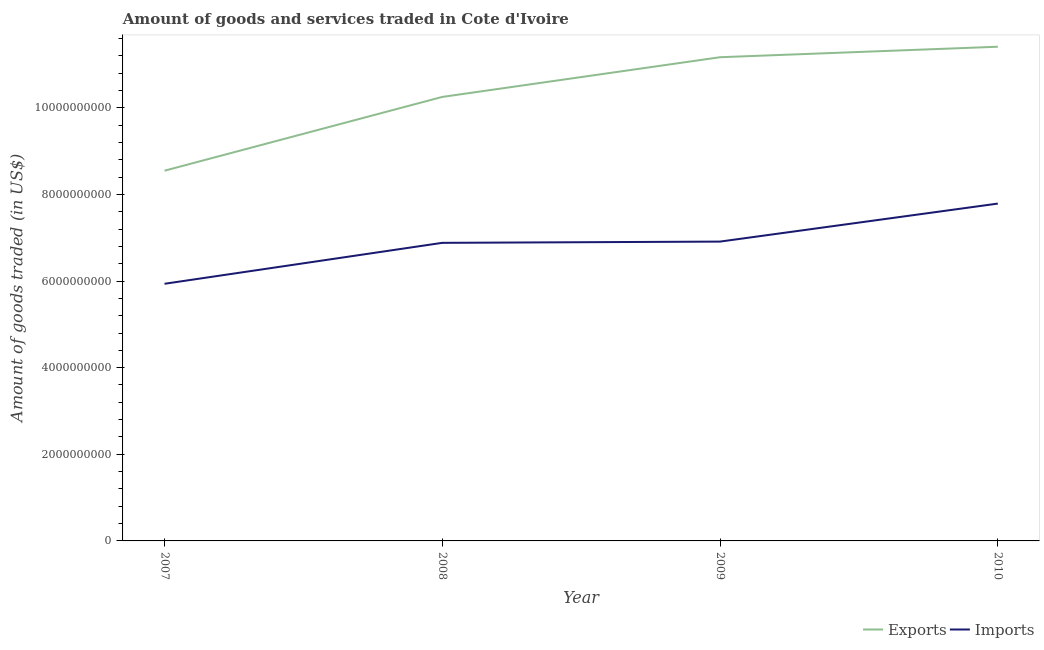Is the number of lines equal to the number of legend labels?
Ensure brevity in your answer.  Yes. What is the amount of goods imported in 2009?
Give a very brief answer. 6.91e+09. Across all years, what is the maximum amount of goods exported?
Offer a very short reply. 1.14e+1. Across all years, what is the minimum amount of goods imported?
Give a very brief answer. 5.94e+09. In which year was the amount of goods imported maximum?
Provide a short and direct response. 2010. What is the total amount of goods exported in the graph?
Your answer should be compact. 4.14e+1. What is the difference between the amount of goods exported in 2007 and that in 2009?
Ensure brevity in your answer.  -2.62e+09. What is the difference between the amount of goods imported in 2008 and the amount of goods exported in 2009?
Your response must be concise. -4.29e+09. What is the average amount of goods exported per year?
Your response must be concise. 1.03e+1. In the year 2010, what is the difference between the amount of goods exported and amount of goods imported?
Give a very brief answer. 3.62e+09. What is the ratio of the amount of goods exported in 2007 to that in 2008?
Your response must be concise. 0.83. Is the amount of goods imported in 2008 less than that in 2010?
Keep it short and to the point. Yes. Is the difference between the amount of goods exported in 2009 and 2010 greater than the difference between the amount of goods imported in 2009 and 2010?
Your answer should be compact. Yes. What is the difference between the highest and the second highest amount of goods exported?
Give a very brief answer. 2.42e+08. What is the difference between the highest and the lowest amount of goods imported?
Give a very brief answer. 1.85e+09. Is the sum of the amount of goods imported in 2007 and 2008 greater than the maximum amount of goods exported across all years?
Your response must be concise. Yes. Does the amount of goods imported monotonically increase over the years?
Your answer should be compact. Yes. Is the amount of goods imported strictly greater than the amount of goods exported over the years?
Your response must be concise. No. Is the amount of goods exported strictly less than the amount of goods imported over the years?
Provide a succinct answer. No. How many years are there in the graph?
Make the answer very short. 4. What is the difference between two consecutive major ticks on the Y-axis?
Offer a very short reply. 2.00e+09. Does the graph contain any zero values?
Provide a succinct answer. No. Does the graph contain grids?
Provide a succinct answer. No. Where does the legend appear in the graph?
Your answer should be compact. Bottom right. How are the legend labels stacked?
Keep it short and to the point. Horizontal. What is the title of the graph?
Make the answer very short. Amount of goods and services traded in Cote d'Ivoire. What is the label or title of the Y-axis?
Keep it short and to the point. Amount of goods traded (in US$). What is the Amount of goods traded (in US$) of Exports in 2007?
Make the answer very short. 8.55e+09. What is the Amount of goods traded (in US$) of Imports in 2007?
Your answer should be very brief. 5.94e+09. What is the Amount of goods traded (in US$) in Exports in 2008?
Offer a terse response. 1.03e+1. What is the Amount of goods traded (in US$) of Imports in 2008?
Ensure brevity in your answer.  6.88e+09. What is the Amount of goods traded (in US$) in Exports in 2009?
Your response must be concise. 1.12e+1. What is the Amount of goods traded (in US$) of Imports in 2009?
Give a very brief answer. 6.91e+09. What is the Amount of goods traded (in US$) in Exports in 2010?
Your answer should be compact. 1.14e+1. What is the Amount of goods traded (in US$) in Imports in 2010?
Your answer should be compact. 7.79e+09. Across all years, what is the maximum Amount of goods traded (in US$) in Exports?
Keep it short and to the point. 1.14e+1. Across all years, what is the maximum Amount of goods traded (in US$) in Imports?
Ensure brevity in your answer.  7.79e+09. Across all years, what is the minimum Amount of goods traded (in US$) in Exports?
Your response must be concise. 8.55e+09. Across all years, what is the minimum Amount of goods traded (in US$) in Imports?
Offer a terse response. 5.94e+09. What is the total Amount of goods traded (in US$) of Exports in the graph?
Your answer should be very brief. 4.14e+1. What is the total Amount of goods traded (in US$) of Imports in the graph?
Your answer should be very brief. 2.75e+1. What is the difference between the Amount of goods traded (in US$) in Exports in 2007 and that in 2008?
Offer a terse response. -1.70e+09. What is the difference between the Amount of goods traded (in US$) of Imports in 2007 and that in 2008?
Ensure brevity in your answer.  -9.45e+08. What is the difference between the Amount of goods traded (in US$) of Exports in 2007 and that in 2009?
Keep it short and to the point. -2.62e+09. What is the difference between the Amount of goods traded (in US$) of Imports in 2007 and that in 2009?
Ensure brevity in your answer.  -9.74e+08. What is the difference between the Amount of goods traded (in US$) of Exports in 2007 and that in 2010?
Your response must be concise. -2.86e+09. What is the difference between the Amount of goods traded (in US$) in Imports in 2007 and that in 2010?
Offer a terse response. -1.85e+09. What is the difference between the Amount of goods traded (in US$) of Exports in 2008 and that in 2009?
Your response must be concise. -9.17e+08. What is the difference between the Amount of goods traded (in US$) in Imports in 2008 and that in 2009?
Give a very brief answer. -2.90e+07. What is the difference between the Amount of goods traded (in US$) of Exports in 2008 and that in 2010?
Ensure brevity in your answer.  -1.16e+09. What is the difference between the Amount of goods traded (in US$) in Imports in 2008 and that in 2010?
Keep it short and to the point. -9.06e+08. What is the difference between the Amount of goods traded (in US$) in Exports in 2009 and that in 2010?
Ensure brevity in your answer.  -2.42e+08. What is the difference between the Amount of goods traded (in US$) in Imports in 2009 and that in 2010?
Keep it short and to the point. -8.77e+08. What is the difference between the Amount of goods traded (in US$) of Exports in 2007 and the Amount of goods traded (in US$) of Imports in 2008?
Provide a short and direct response. 1.67e+09. What is the difference between the Amount of goods traded (in US$) of Exports in 2007 and the Amount of goods traded (in US$) of Imports in 2009?
Offer a very short reply. 1.64e+09. What is the difference between the Amount of goods traded (in US$) in Exports in 2007 and the Amount of goods traded (in US$) in Imports in 2010?
Ensure brevity in your answer.  7.59e+08. What is the difference between the Amount of goods traded (in US$) of Exports in 2008 and the Amount of goods traded (in US$) of Imports in 2009?
Provide a short and direct response. 3.34e+09. What is the difference between the Amount of goods traded (in US$) of Exports in 2008 and the Amount of goods traded (in US$) of Imports in 2010?
Provide a succinct answer. 2.46e+09. What is the difference between the Amount of goods traded (in US$) of Exports in 2009 and the Amount of goods traded (in US$) of Imports in 2010?
Your answer should be compact. 3.38e+09. What is the average Amount of goods traded (in US$) in Exports per year?
Give a very brief answer. 1.03e+1. What is the average Amount of goods traded (in US$) in Imports per year?
Your answer should be very brief. 6.88e+09. In the year 2007, what is the difference between the Amount of goods traded (in US$) of Exports and Amount of goods traded (in US$) of Imports?
Your response must be concise. 2.61e+09. In the year 2008, what is the difference between the Amount of goods traded (in US$) in Exports and Amount of goods traded (in US$) in Imports?
Ensure brevity in your answer.  3.37e+09. In the year 2009, what is the difference between the Amount of goods traded (in US$) in Exports and Amount of goods traded (in US$) in Imports?
Make the answer very short. 4.26e+09. In the year 2010, what is the difference between the Amount of goods traded (in US$) of Exports and Amount of goods traded (in US$) of Imports?
Ensure brevity in your answer.  3.62e+09. What is the ratio of the Amount of goods traded (in US$) in Exports in 2007 to that in 2008?
Keep it short and to the point. 0.83. What is the ratio of the Amount of goods traded (in US$) in Imports in 2007 to that in 2008?
Offer a very short reply. 0.86. What is the ratio of the Amount of goods traded (in US$) in Exports in 2007 to that in 2009?
Offer a very short reply. 0.77. What is the ratio of the Amount of goods traded (in US$) in Imports in 2007 to that in 2009?
Provide a succinct answer. 0.86. What is the ratio of the Amount of goods traded (in US$) in Exports in 2007 to that in 2010?
Provide a short and direct response. 0.75. What is the ratio of the Amount of goods traded (in US$) of Imports in 2007 to that in 2010?
Offer a very short reply. 0.76. What is the ratio of the Amount of goods traded (in US$) in Exports in 2008 to that in 2009?
Your answer should be very brief. 0.92. What is the ratio of the Amount of goods traded (in US$) of Exports in 2008 to that in 2010?
Your answer should be very brief. 0.9. What is the ratio of the Amount of goods traded (in US$) in Imports in 2008 to that in 2010?
Give a very brief answer. 0.88. What is the ratio of the Amount of goods traded (in US$) in Exports in 2009 to that in 2010?
Provide a short and direct response. 0.98. What is the ratio of the Amount of goods traded (in US$) of Imports in 2009 to that in 2010?
Give a very brief answer. 0.89. What is the difference between the highest and the second highest Amount of goods traded (in US$) in Exports?
Make the answer very short. 2.42e+08. What is the difference between the highest and the second highest Amount of goods traded (in US$) of Imports?
Make the answer very short. 8.77e+08. What is the difference between the highest and the lowest Amount of goods traded (in US$) in Exports?
Give a very brief answer. 2.86e+09. What is the difference between the highest and the lowest Amount of goods traded (in US$) in Imports?
Offer a terse response. 1.85e+09. 